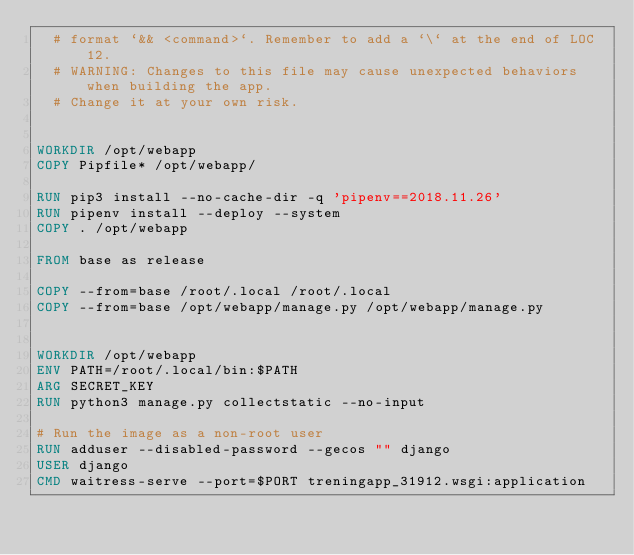<code> <loc_0><loc_0><loc_500><loc_500><_Dockerfile_>  # format `&& <command>`. Remember to add a `\` at the end of LOC 12.
  # WARNING: Changes to this file may cause unexpected behaviors when building the app.
  # Change it at your own risk.


WORKDIR /opt/webapp
COPY Pipfile* /opt/webapp/

RUN pip3 install --no-cache-dir -q 'pipenv==2018.11.26' 
RUN pipenv install --deploy --system
COPY . /opt/webapp

FROM base as release

COPY --from=base /root/.local /root/.local
COPY --from=base /opt/webapp/manage.py /opt/webapp/manage.py


WORKDIR /opt/webapp
ENV PATH=/root/.local/bin:$PATH
ARG SECRET_KEY 
RUN python3 manage.py collectstatic --no-input

# Run the image as a non-root user
RUN adduser --disabled-password --gecos "" django
USER django
CMD waitress-serve --port=$PORT treningapp_31912.wsgi:application
</code> 